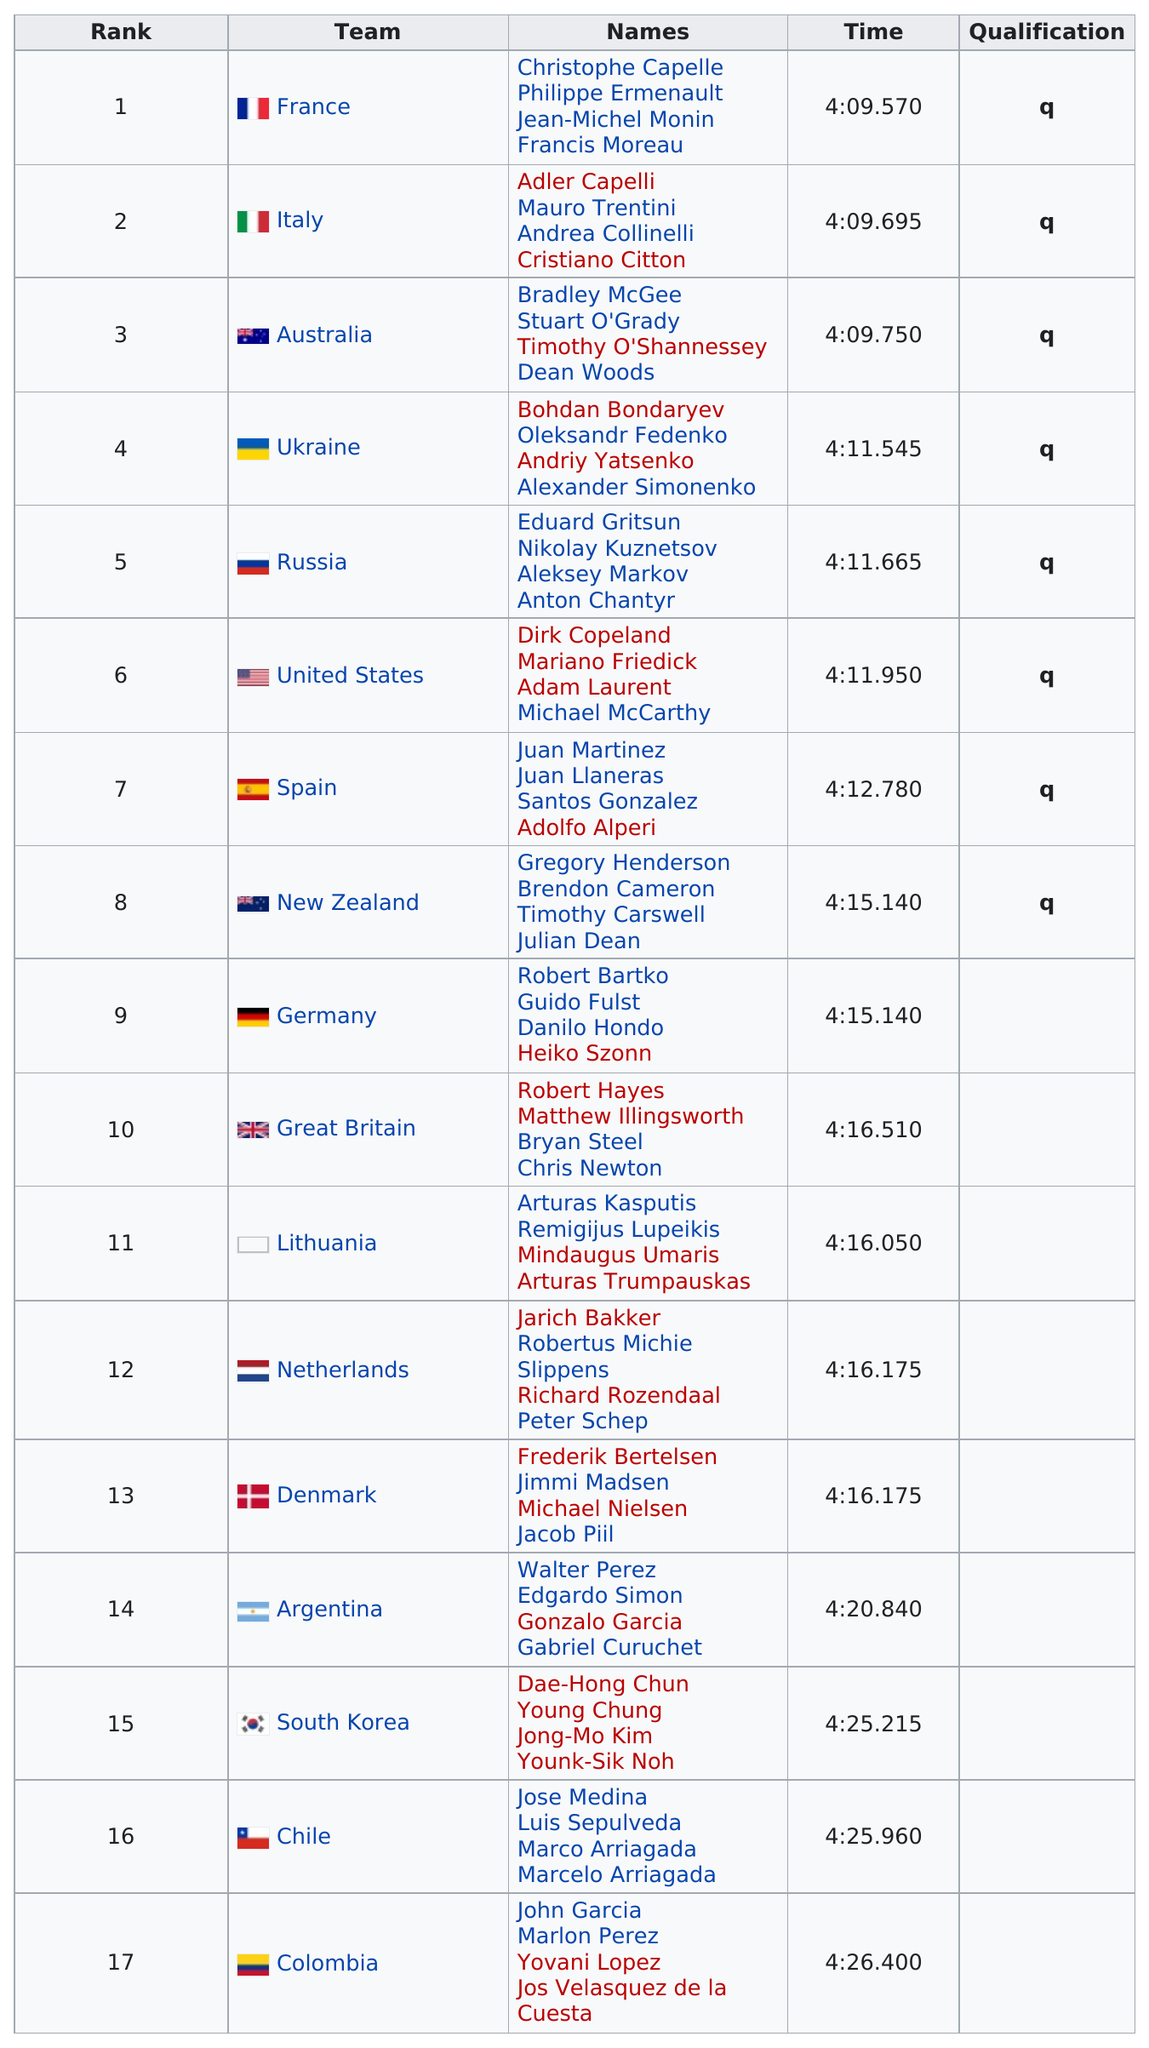Indicate a few pertinent items in this graphic. The team that ranked first in a certain country is France. The number of teams that finished better than Spain in the Men's Team Pursuit event at the 1996 Summer Olympics was six. Other than Italy, there are currently 7 teams that have qualified for the World Cup. Seventeen consecutive rankings are listed. Out of the teams that finished the race faster than 4 hours and 10 minutes, 3 of them finished faster than 4:10. 